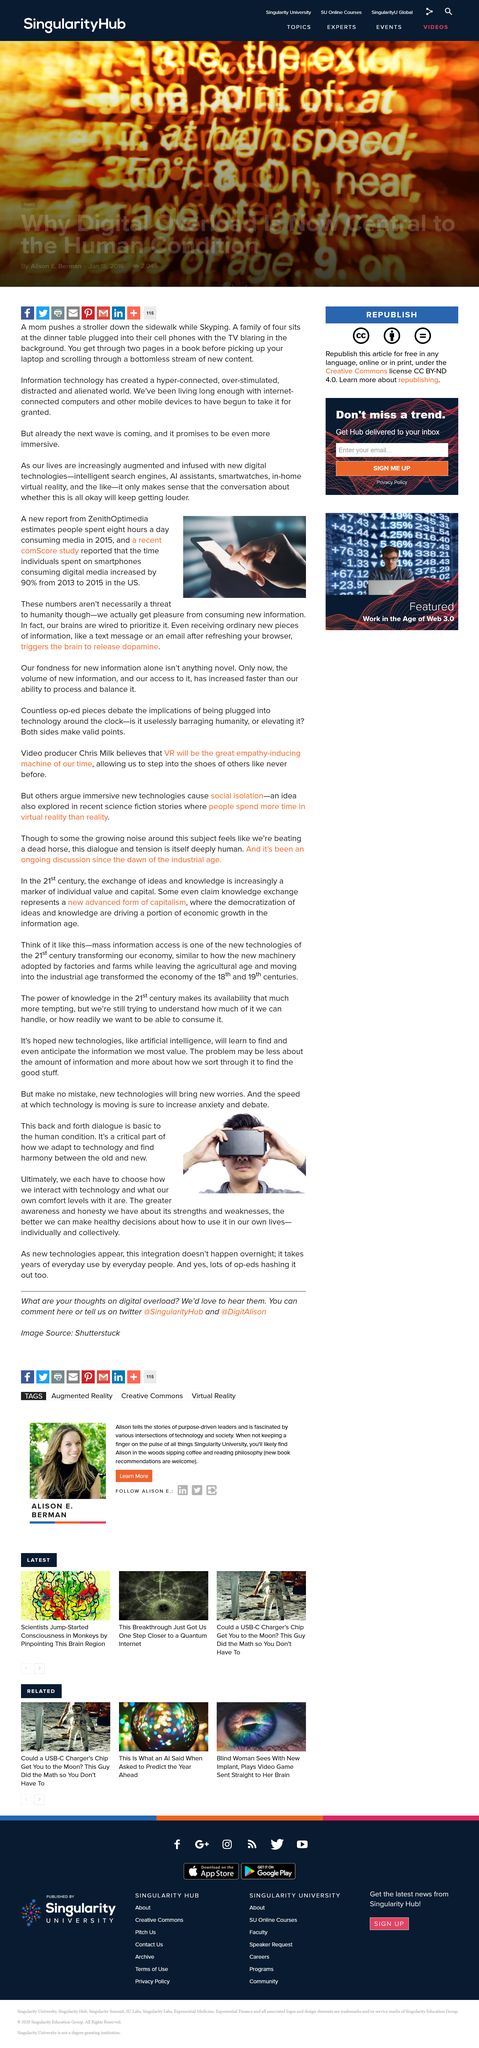Highlight a few significant elements in this photo. The exchange does not occur in a one-directional manner, but rather back and forth. The speed at which technology is advancing is causing an increase in anxiety and debate. The use of media increased by 90% from 2013 to 2015. When you receive a message, your brain releases dopamine, a chemical that plays a key role in the reward and pleasure center of the brain. What new technologies will bring? They bring along new worries. 